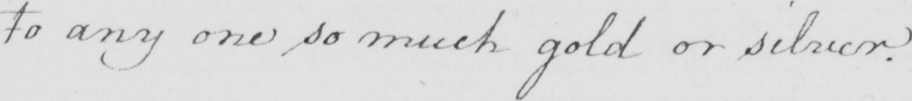What text is written in this handwritten line? to any one so much gold or silver . 